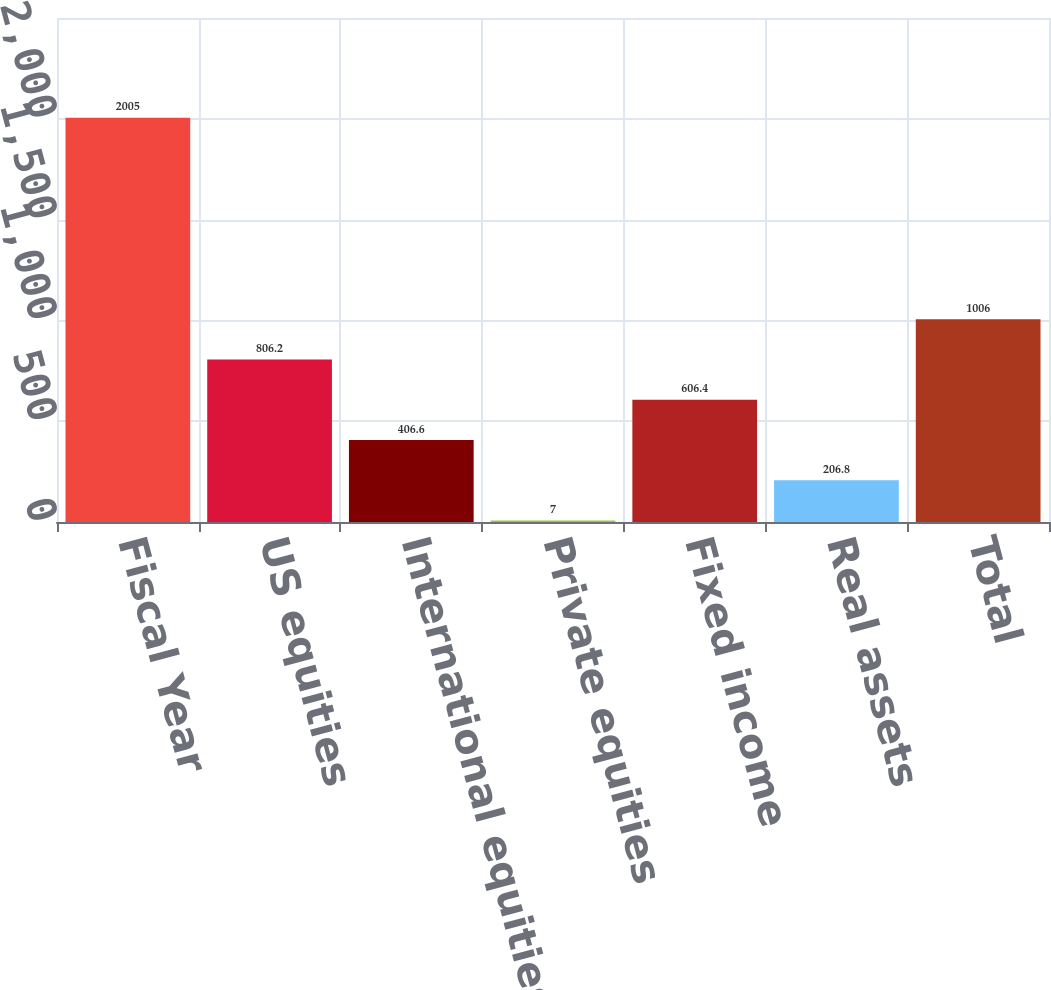<chart> <loc_0><loc_0><loc_500><loc_500><bar_chart><fcel>Fiscal Year<fcel>US equities<fcel>International equities<fcel>Private equities<fcel>Fixed income<fcel>Real assets<fcel>Total<nl><fcel>2005<fcel>806.2<fcel>406.6<fcel>7<fcel>606.4<fcel>206.8<fcel>1006<nl></chart> 